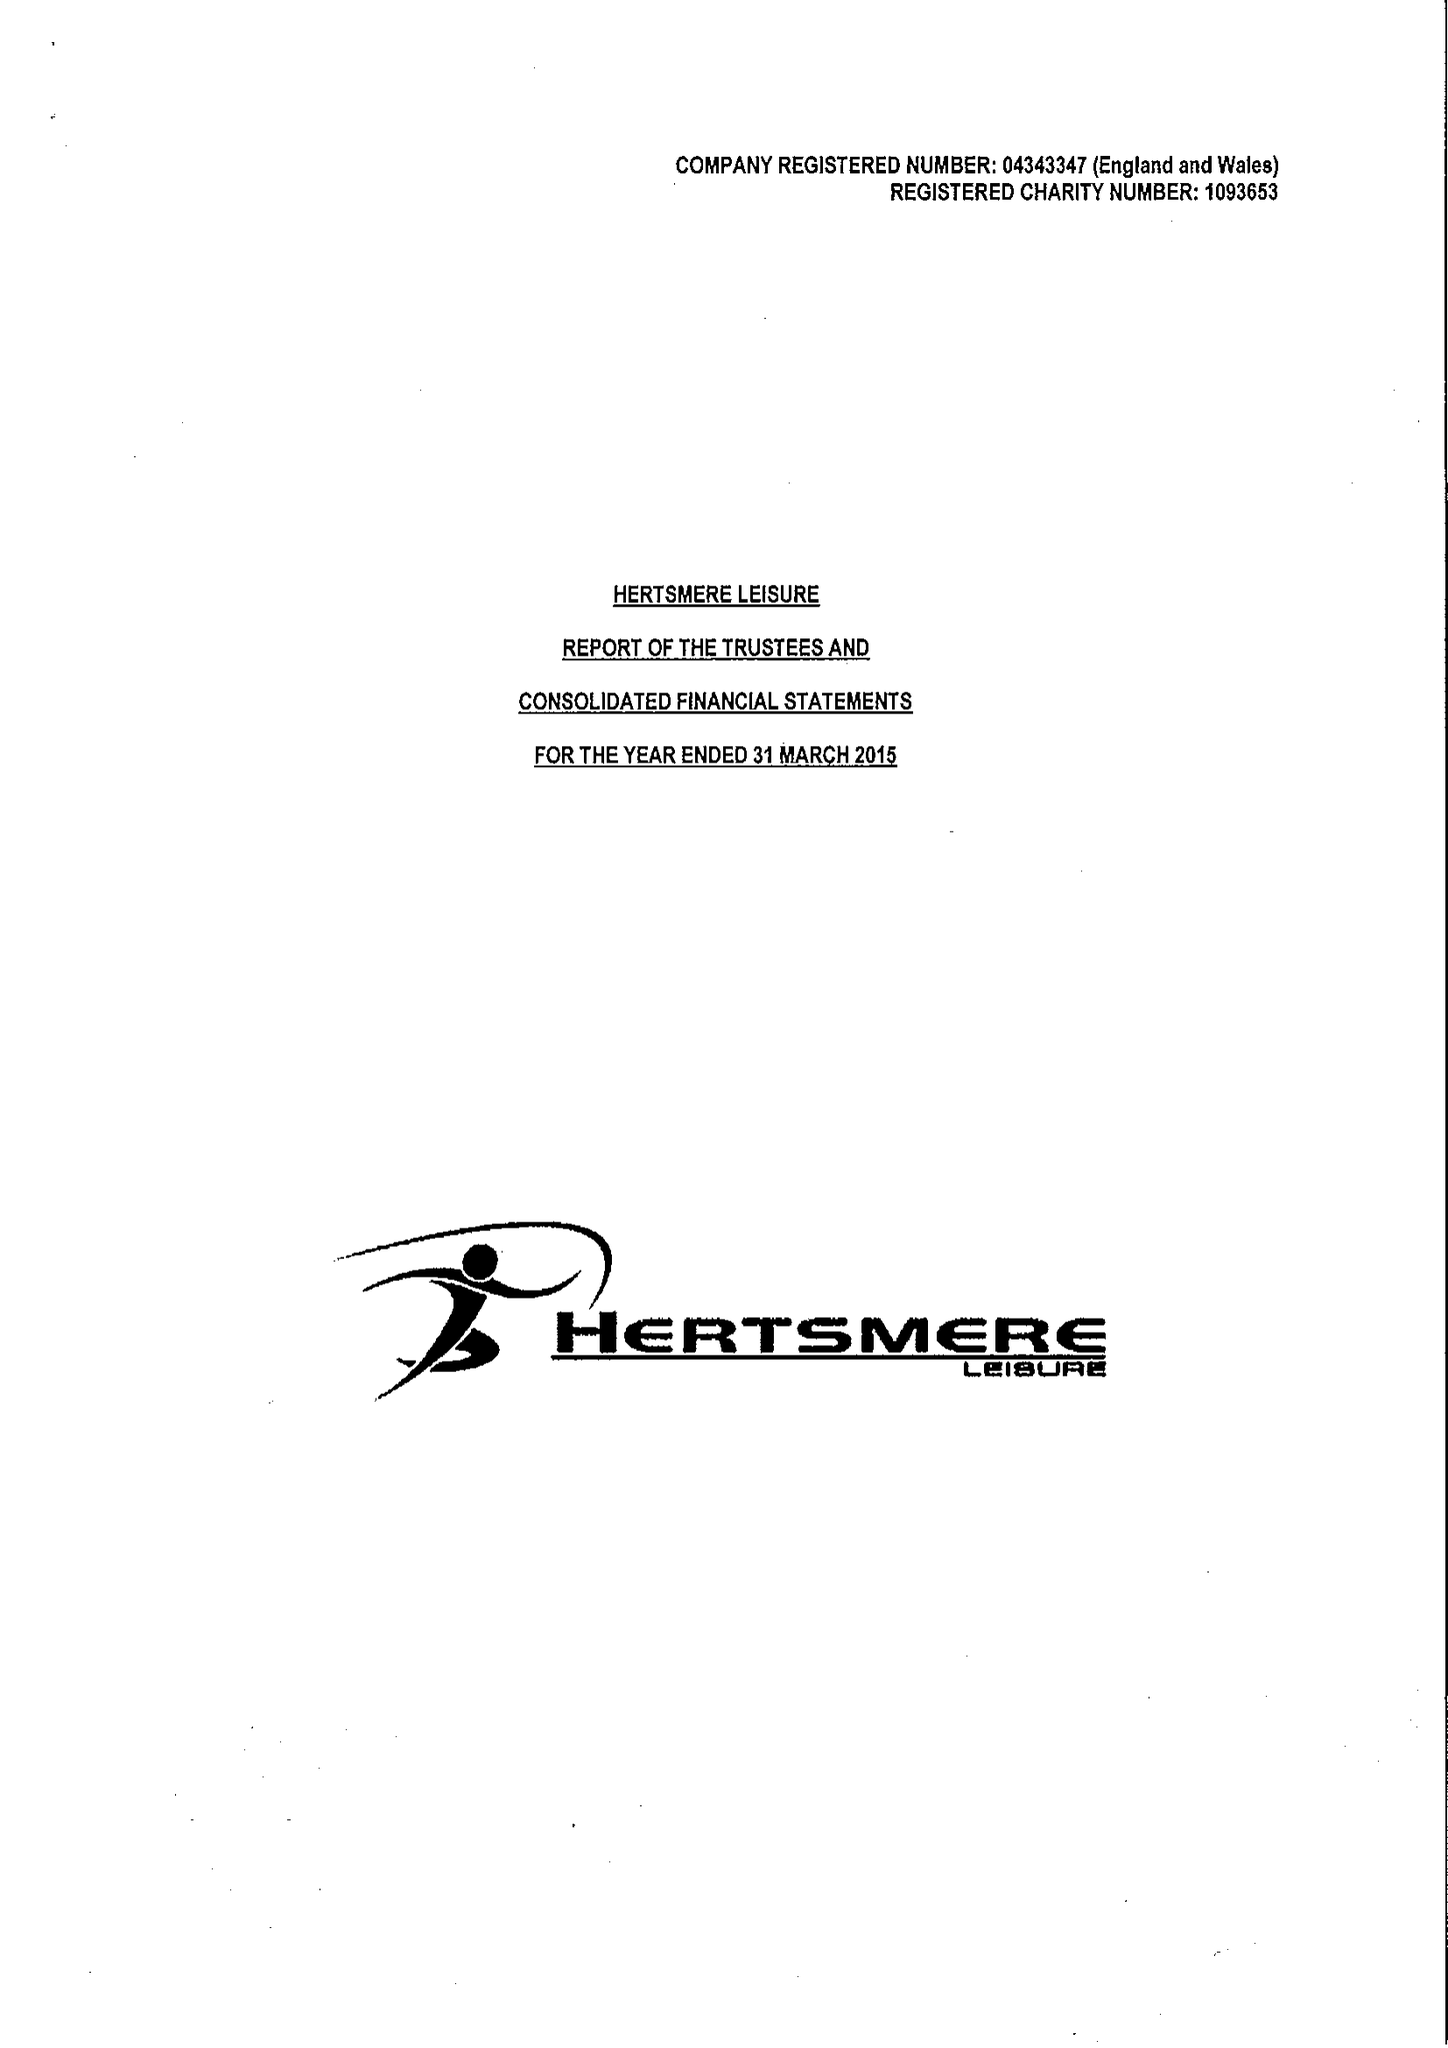What is the value for the income_annually_in_british_pounds?
Answer the question using a single word or phrase. 18887811.00 